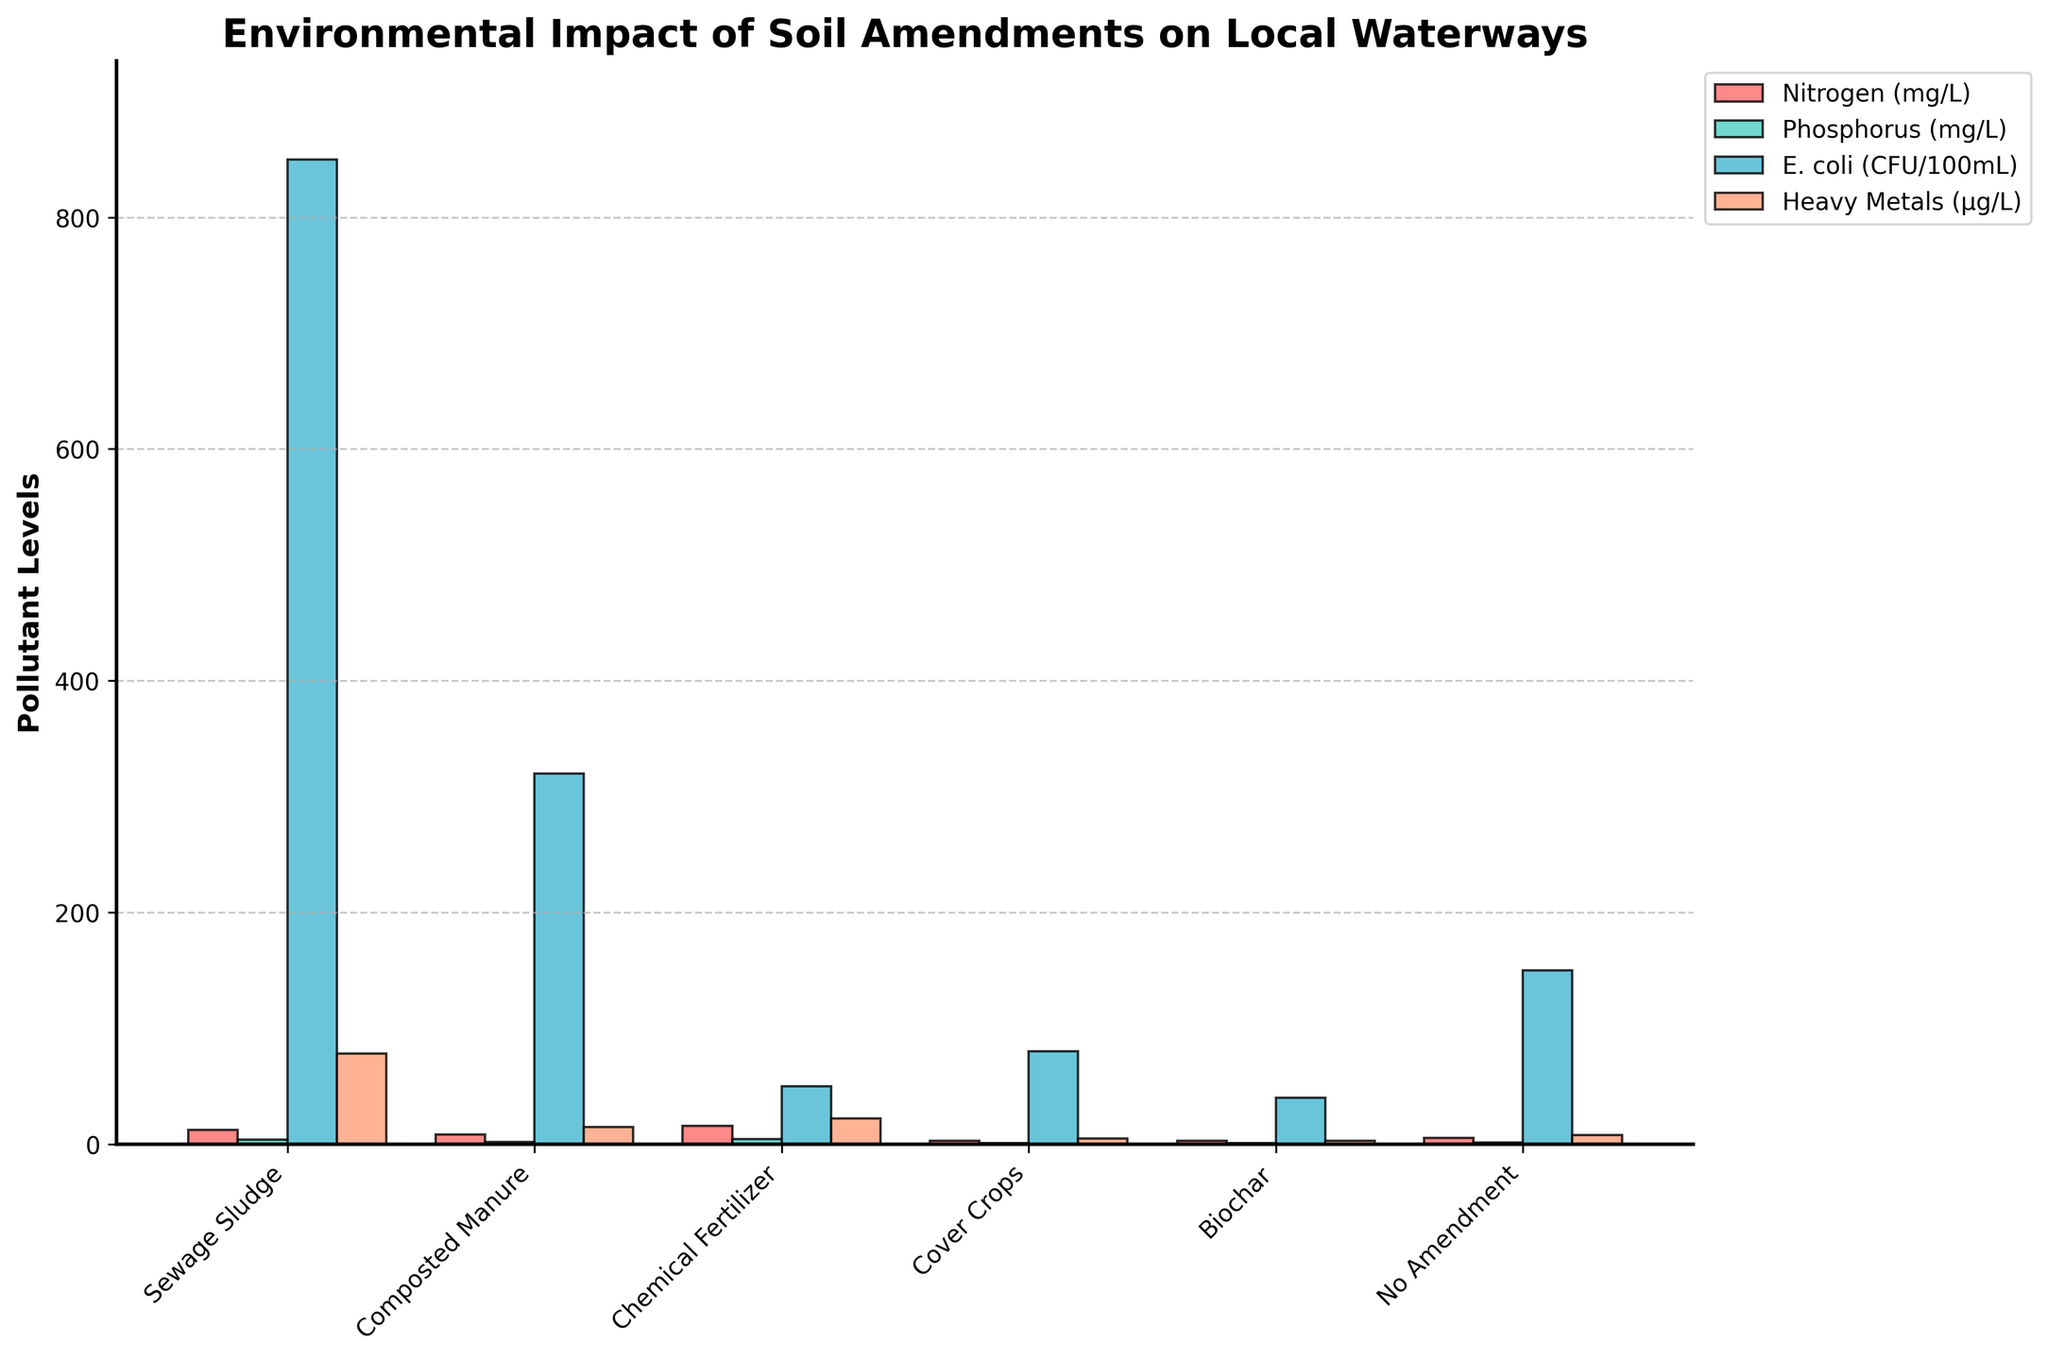What is the amendment with the highest Nitrogen level? To find the highest Nitrogen level, we compare the heights of the bars for Nitrogen (mg/L) across all amendments. The tallest bar for Nitrogen belongs to Chemical Fertilizer.
Answer: Chemical Fertilizer Which amendment has the lowest level of Heavy Metals? For Heavy Metals, we check the height of the bars labeled for Heavy Metals (µg/L). The shortest bar is for Biochar.
Answer: Biochar How does the E. coli level of Sewage Sludge compare to Composted Manure? By comparing the heights of the bars for E. coli (CFU/100mL) for Sewage Sludge and Composted Manure, we see that the bar for Sewage Sludge is much taller than that for Composted Manure.
Answer: Sewage Sludge has higher E. coli levels What is the average level of Phosphorus across all amendments? To find the average Phosphorus level, we sum the values for all amendments: 3.8 (Sewage Sludge) + 2.1 (Composted Manure) + 4.5 (Chemical Fertilizer) + 0.9 (Cover Crops) + 0.7 (Biochar) + 1.5 (No Amendment). This gives us a total of 13.5. There are 6 amendments, so we divide 13.5 by 6 to obtain the average.
Answer: 2.25 mg/L Which amendment has the greatest difference between Nitrogen and Phosphorus levels? We calculate the difference between Nitrogen and Phosphorus levels for each amendment and identify the largest gap. Calculations are: 
- Sewage Sludge: 12.5 - 3.8 = 8.7
- Composted Manure: 8.2 - 2.1 = 6.1
- Chemical Fertilizer: 15.7 - 4.5 = 11.2
- Cover Crops: 3.1 - 0.9 = 2.2
- Biochar: 2.8 - 0.7 = 2.1
- No Amendment: 5.4 - 1.5 = 3.9
The greatest difference is with the Chemical Fertilizer.
Answer: Chemical Fertilizer What is the total E. coli count if using Biochar and Cover Crops together? We add the E. coli levels of Biochar and Cover Crops. The Biochar level is 40 CFU/100mL, and the Cover Crops level is 80 CFU/100mL. The total is 40 + 80 = 120 CFU/100mL.
Answer: 120 CFU/100mL Which amendment has the second-lowest Phosphorus level? We list the Phosphorus levels in ascending order: 0.7 (Biochar), 0.9 (Cover Crops), 1.5 (No Amendment), 2.1 (Composted Manure), 3.8 (Sewage Sludge), and 4.5 (Chemical Fertilizer). The second-lowest Phosphorus level is for Cover Crops.
Answer: Cover Crops How many times higher is the level of Heavy Metals in Sewage Sludge compared to Biochar? We divide the Heavy Metals level in Sewage Sludge (78 µg/L) by the level in Biochar (3 µg/L) to find the ratio. 78 / 3 = 26. Thus, Sewage Sludge has 26 times more Heavy Metals than Biochar.
Answer: 26 times 